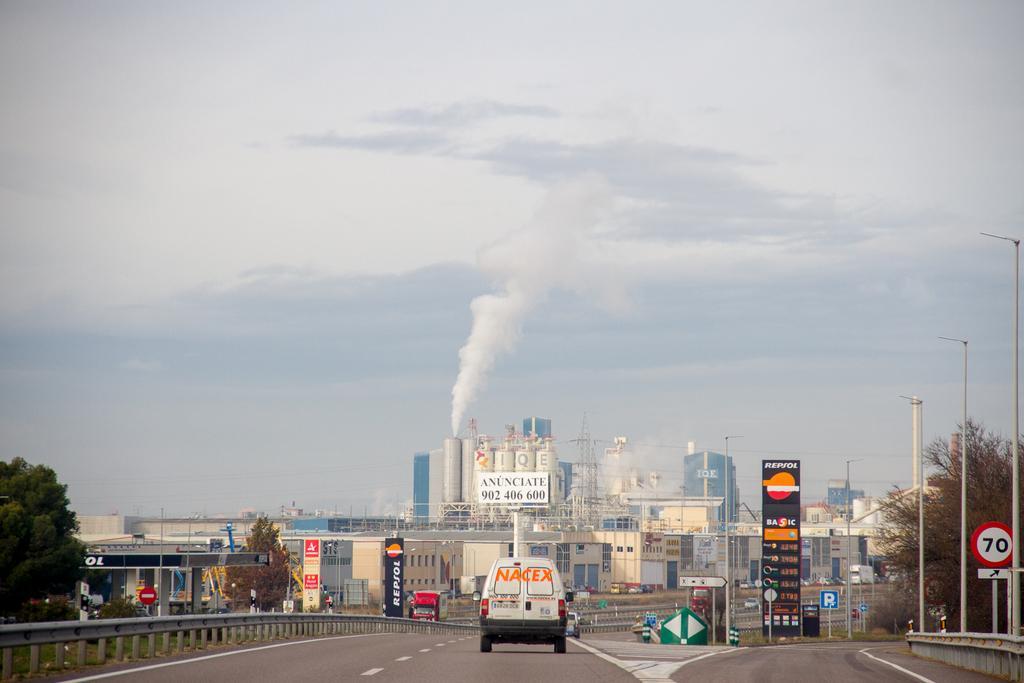In one or two sentences, can you explain what this image depicts? In this picture we can observe a vehicle on the road. There are some trees and poles on either sides of the road. In the background we can observe an industry. There is a smoke. In the background we can observe a sky. 